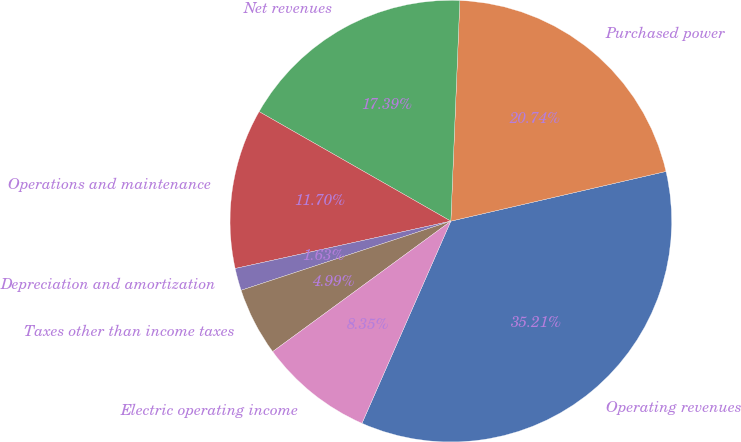Convert chart to OTSL. <chart><loc_0><loc_0><loc_500><loc_500><pie_chart><fcel>Operating revenues<fcel>Purchased power<fcel>Net revenues<fcel>Operations and maintenance<fcel>Depreciation and amortization<fcel>Taxes other than income taxes<fcel>Electric operating income<nl><fcel>35.21%<fcel>20.74%<fcel>17.39%<fcel>11.7%<fcel>1.63%<fcel>4.99%<fcel>8.35%<nl></chart> 